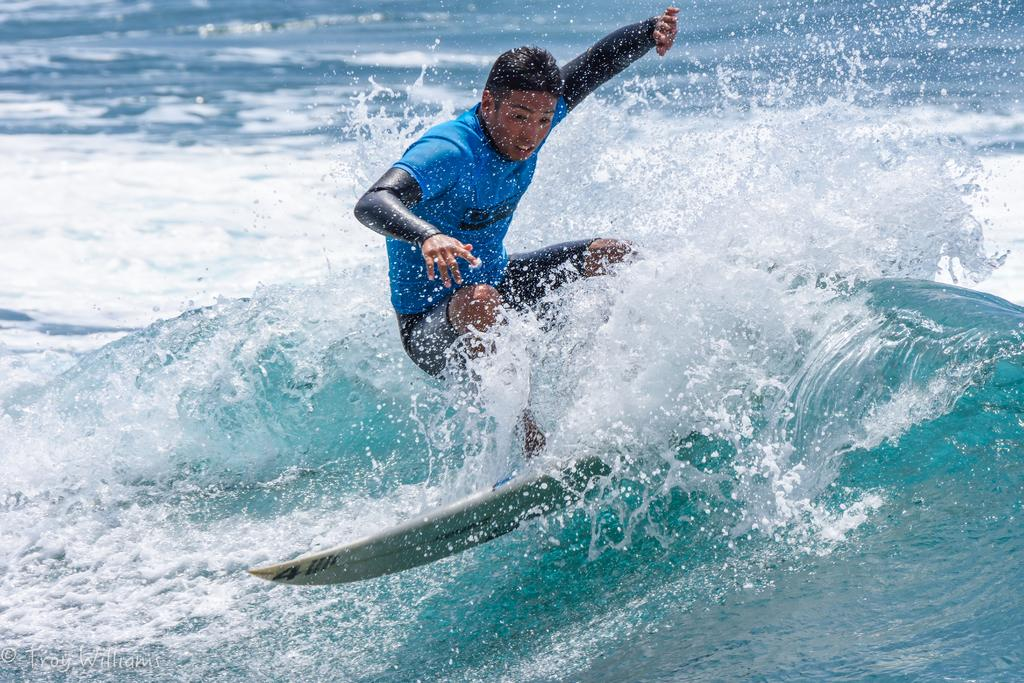What is the person in the image doing? The person is surfing in the image. Where is the person located while performing this activity? The person is in the water. What can be observed in the water around the person? There are waves visible in the image. What type of lock is the person using to secure their shirt in the image? There is no lock or shirt mentioned in the image; the person is surfing in the water with waves visible. 